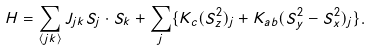Convert formula to latex. <formula><loc_0><loc_0><loc_500><loc_500>H = \sum _ { \langle j k \rangle } J _ { j k } { S } _ { j } \cdot { S } _ { k } + \sum _ { j } \{ K _ { c } ( S _ { z } ^ { 2 } ) _ { j } + K _ { a b } ( S _ { y } ^ { 2 } - S _ { x } ^ { 2 } ) _ { j } \} .</formula> 